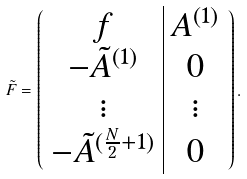<formula> <loc_0><loc_0><loc_500><loc_500>\tilde { F } = \left ( \begin{array} { c | c } f & A ^ { ( 1 ) } \\ - \tilde { A } ^ { ( 1 ) } & 0 \\ \vdots & \vdots \\ - \tilde { A } ^ { ( \frac { N } { 2 } + 1 ) } & 0 \end{array} \right ) .</formula> 